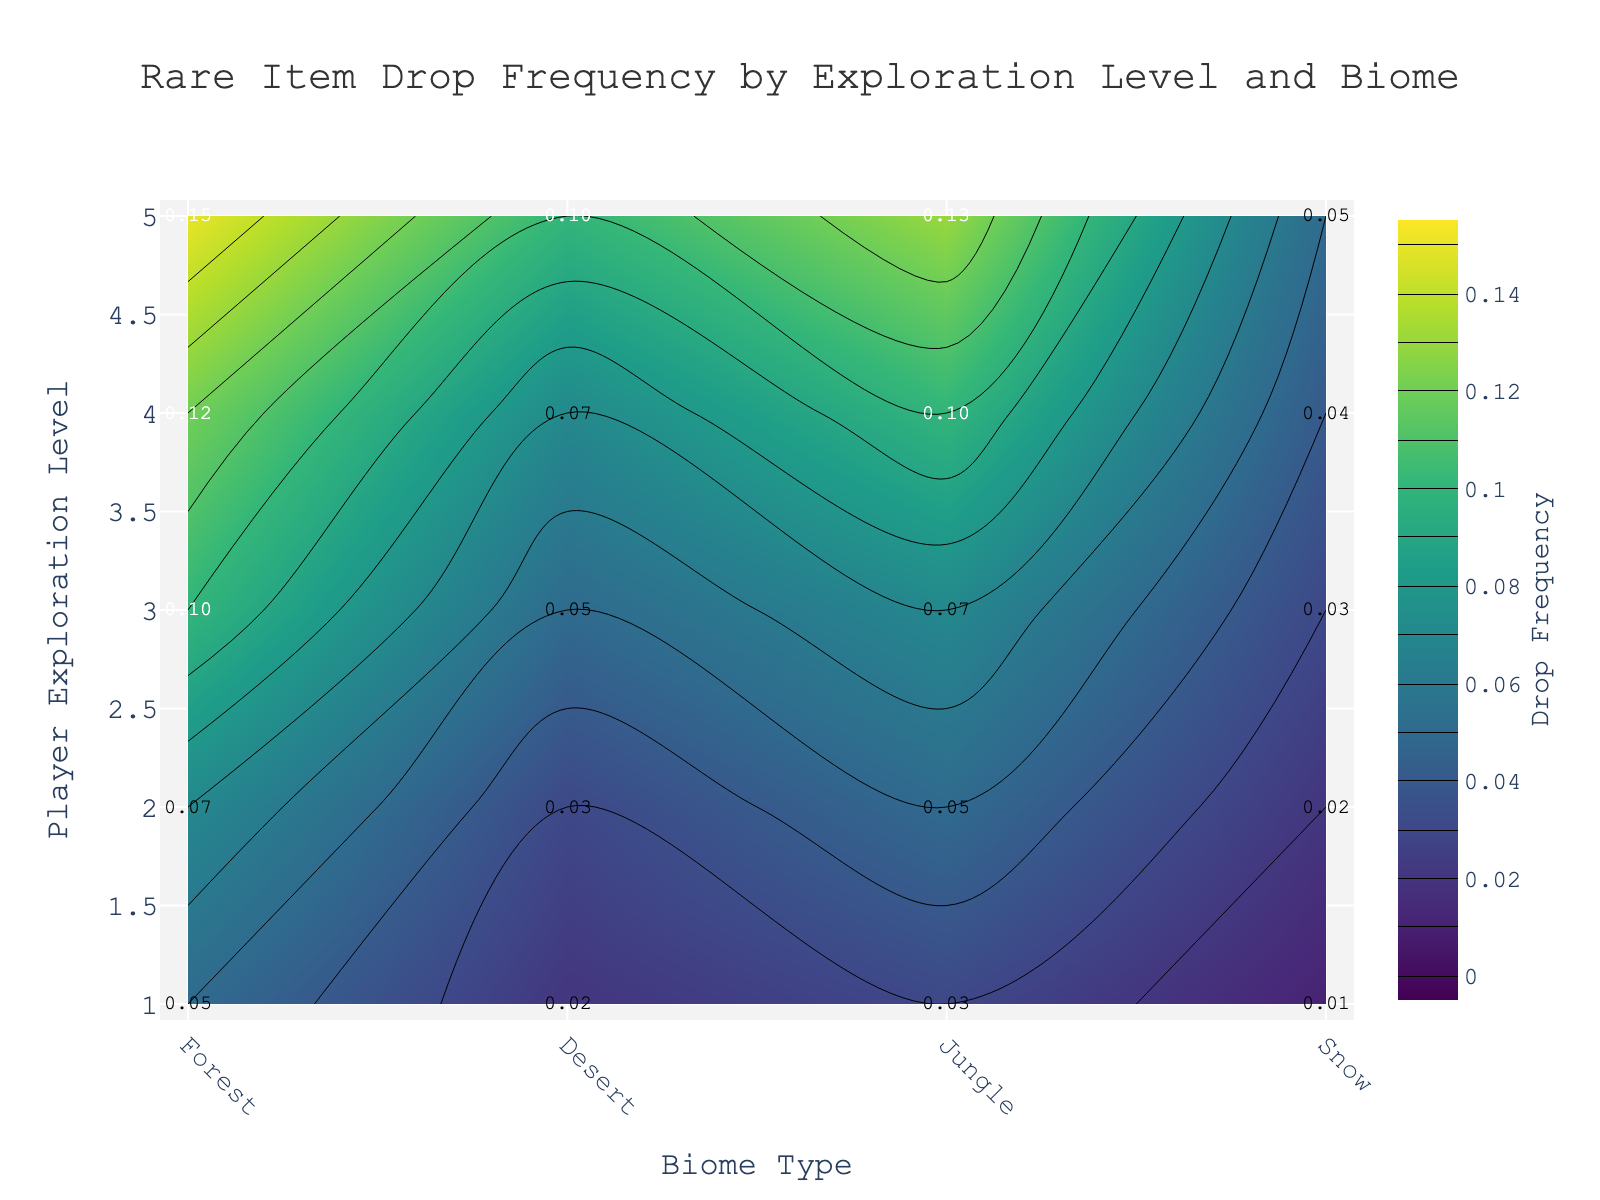What is the title of the figure? The title is displayed at the top of the figure. It helps users understand the main topic or focus of the visualization.
Answer: Rare Item Drop Frequency by Exploration Level and Biome Which player exploration level has the highest rare item drop frequency in the Jungle biome? Locate the Jungle biome along the x-axis and find the corresponding highest value along the y-axis which represents exploration levels.
Answer: 5 What is the rare item drop frequency for a player at exploration level 3 in the Desert biome? Find the point where exploration level 3 intersects with the Desert biome on the contour plot and read the frequency value.
Answer: 0.05 How does the rare item drop frequency change from Forest to Snow biome at exploration level 4? Compare the values in the contour plot for exploration level 4 across the Forest and Snow biomes.
Answer: Decreases from 0.12 to 0.04 What is the average rare item drop frequency for players in the Forest biome across all exploration levels? Calculate the mean of the frequencies in the Forest biome across all exploration levels, i.e., (0.05 + 0.07 + 0.10 + 0.12 + 0.15) / 5.
Answer: 0.098 Which biome shows the least variation in rare item drop frequency from exploration levels 1 to 5? Examine the range of frequencies within each biome over all exploration levels. The least variation is determined by the smallest difference between the maximum and minimum values.
Answer: Snow At which player exploration level and biome is the rare item drop frequency the lowest? Identify the lowest point on the contour plot by comparing frequencies at all exploration levels and biomes.
Answer: Exploration level 1, Snow biome Which biome has the highest average rare item drop frequency for all exploration levels combined? Calculate the average drop frequency for each biome and compare. For Forest: (0.05 + 0.07 + 0.10 + 0.12 + 0.15) / 5, Desert: (0.02 + 0.03 + 0.05 + 0.07 + 0.10) / 5, Jungle: (0.03 + 0.05 + 0.07 + 0.10 + 0.13) / 5, Snow: (0.01 + 0.02 + 0.03 + 0.04 + 0.05) / 5. Jungle has the highest.
Answer: Jungle How does the color change on the contour plot between the lowest and highest drop frequency values? Observe the colors mapped from the contour plot's color scale, with darker shades representing lower frequencies and brighter shades indicating higher frequencies.
Answer: The color changes from dark to bright For a player at exploration level 2, which biome provides better chances of obtaining rare items, Desert or Jungle? Compare the rare item drop frequencies for exploration level 2 in both the Desert and Jungle biomes.
Answer: Jungle 